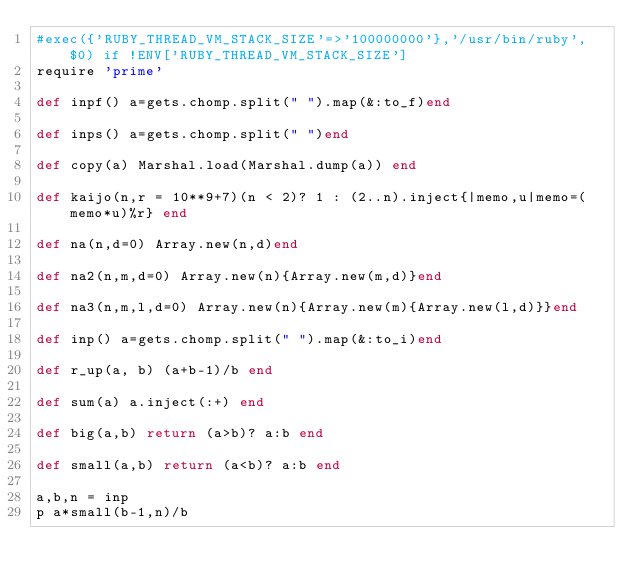Convert code to text. <code><loc_0><loc_0><loc_500><loc_500><_Ruby_>#exec({'RUBY_THREAD_VM_STACK_SIZE'=>'100000000'},'/usr/bin/ruby', $0) if !ENV['RUBY_THREAD_VM_STACK_SIZE']
require 'prime'

def inpf() a=gets.chomp.split(" ").map(&:to_f)end

def inps() a=gets.chomp.split(" ")end

def copy(a) Marshal.load(Marshal.dump(a)) end

def kaijo(n,r = 10**9+7)(n < 2)? 1 : (2..n).inject{|memo,u|memo=(memo*u)%r} end

def na(n,d=0) Array.new(n,d)end

def na2(n,m,d=0) Array.new(n){Array.new(m,d)}end

def na3(n,m,l,d=0) Array.new(n){Array.new(m){Array.new(l,d)}}end

def inp() a=gets.chomp.split(" ").map(&:to_i)end

def r_up(a, b) (a+b-1)/b end

def sum(a) a.inject(:+) end

def big(a,b) return (a>b)? a:b end

def small(a,b) return (a<b)? a:b end

a,b,n = inp
p a*small(b-1,n)/b
</code> 